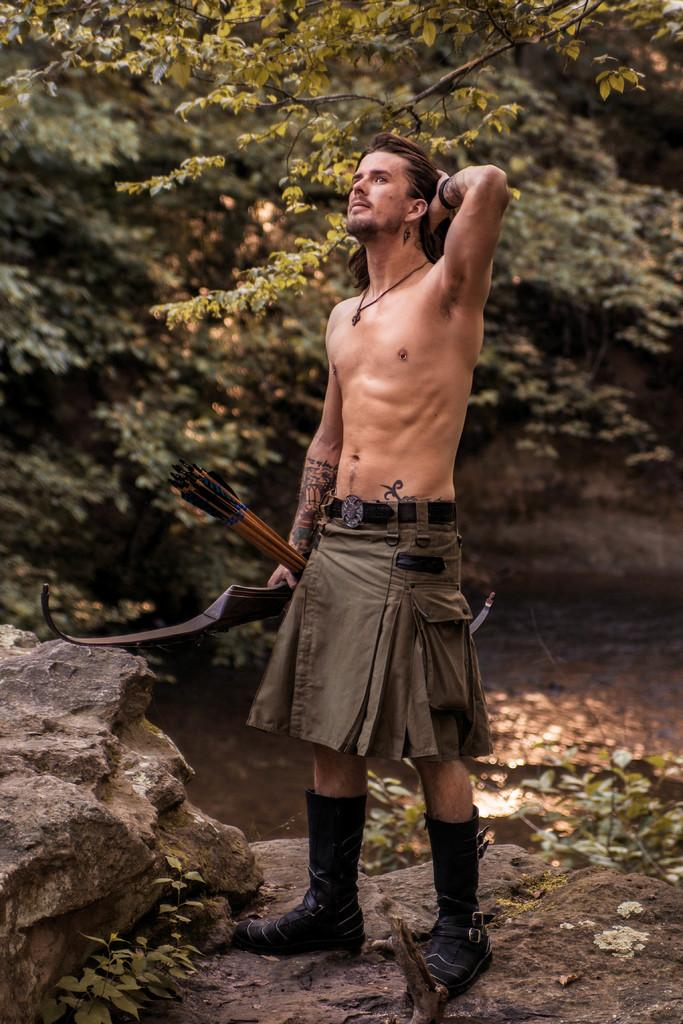What is the main subject of the image? There is a person standing in the image. What is the person holding in the image? The person is holding objects. What type of natural elements can be seen in the image? There are trees, plants, rocks, and water visible in the image. What type of insect is guiding the person in the image? There is no insect present in the image, and therefore no such guiding can be observed. How does the person use the lift in the image? There is no lift present in the image; it features a person standing with objects and natural elements. 